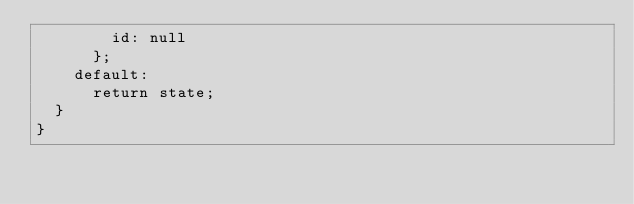Convert code to text. <code><loc_0><loc_0><loc_500><loc_500><_JavaScript_>        id: null
      };
    default:
      return state;
  }
}</code> 